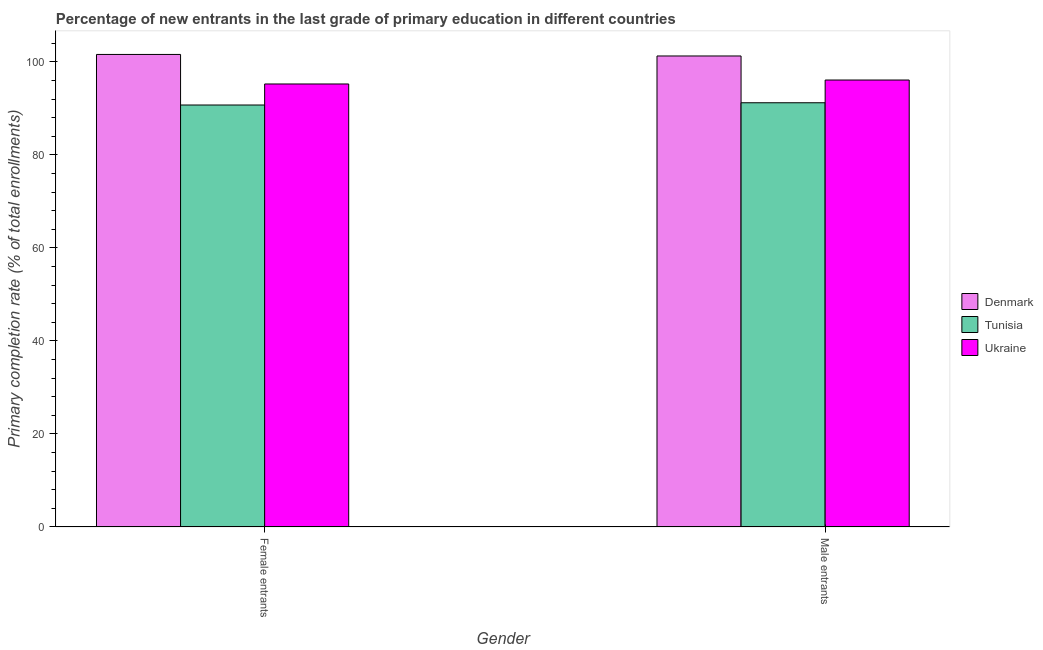How many groups of bars are there?
Your answer should be compact. 2. Are the number of bars on each tick of the X-axis equal?
Make the answer very short. Yes. What is the label of the 1st group of bars from the left?
Make the answer very short. Female entrants. What is the primary completion rate of female entrants in Ukraine?
Ensure brevity in your answer.  95.24. Across all countries, what is the maximum primary completion rate of female entrants?
Offer a terse response. 101.58. Across all countries, what is the minimum primary completion rate of male entrants?
Keep it short and to the point. 91.2. In which country was the primary completion rate of female entrants minimum?
Provide a succinct answer. Tunisia. What is the total primary completion rate of female entrants in the graph?
Your response must be concise. 287.53. What is the difference between the primary completion rate of male entrants in Tunisia and that in Ukraine?
Offer a terse response. -4.89. What is the difference between the primary completion rate of female entrants in Denmark and the primary completion rate of male entrants in Tunisia?
Provide a short and direct response. 10.38. What is the average primary completion rate of female entrants per country?
Give a very brief answer. 95.84. What is the difference between the primary completion rate of male entrants and primary completion rate of female entrants in Denmark?
Ensure brevity in your answer.  -0.33. In how many countries, is the primary completion rate of male entrants greater than 84 %?
Provide a succinct answer. 3. What is the ratio of the primary completion rate of female entrants in Tunisia to that in Denmark?
Your answer should be very brief. 0.89. In how many countries, is the primary completion rate of male entrants greater than the average primary completion rate of male entrants taken over all countries?
Provide a short and direct response. 1. What does the 2nd bar from the left in Male entrants represents?
Give a very brief answer. Tunisia. What does the 2nd bar from the right in Male entrants represents?
Ensure brevity in your answer.  Tunisia. How many bars are there?
Offer a terse response. 6. Are all the bars in the graph horizontal?
Provide a succinct answer. No. How many countries are there in the graph?
Provide a succinct answer. 3. What is the difference between two consecutive major ticks on the Y-axis?
Offer a very short reply. 20. Does the graph contain grids?
Your response must be concise. No. How many legend labels are there?
Provide a succinct answer. 3. What is the title of the graph?
Provide a short and direct response. Percentage of new entrants in the last grade of primary education in different countries. What is the label or title of the X-axis?
Provide a succinct answer. Gender. What is the label or title of the Y-axis?
Your answer should be compact. Primary completion rate (% of total enrollments). What is the Primary completion rate (% of total enrollments) of Denmark in Female entrants?
Make the answer very short. 101.58. What is the Primary completion rate (% of total enrollments) in Tunisia in Female entrants?
Ensure brevity in your answer.  90.72. What is the Primary completion rate (% of total enrollments) of Ukraine in Female entrants?
Your answer should be compact. 95.24. What is the Primary completion rate (% of total enrollments) of Denmark in Male entrants?
Make the answer very short. 101.26. What is the Primary completion rate (% of total enrollments) of Tunisia in Male entrants?
Offer a very short reply. 91.2. What is the Primary completion rate (% of total enrollments) in Ukraine in Male entrants?
Your answer should be compact. 96.09. Across all Gender, what is the maximum Primary completion rate (% of total enrollments) of Denmark?
Keep it short and to the point. 101.58. Across all Gender, what is the maximum Primary completion rate (% of total enrollments) of Tunisia?
Offer a terse response. 91.2. Across all Gender, what is the maximum Primary completion rate (% of total enrollments) in Ukraine?
Your answer should be very brief. 96.09. Across all Gender, what is the minimum Primary completion rate (% of total enrollments) of Denmark?
Make the answer very short. 101.26. Across all Gender, what is the minimum Primary completion rate (% of total enrollments) of Tunisia?
Ensure brevity in your answer.  90.72. Across all Gender, what is the minimum Primary completion rate (% of total enrollments) in Ukraine?
Your answer should be compact. 95.24. What is the total Primary completion rate (% of total enrollments) in Denmark in the graph?
Give a very brief answer. 202.84. What is the total Primary completion rate (% of total enrollments) in Tunisia in the graph?
Ensure brevity in your answer.  181.92. What is the total Primary completion rate (% of total enrollments) of Ukraine in the graph?
Ensure brevity in your answer.  191.32. What is the difference between the Primary completion rate (% of total enrollments) of Denmark in Female entrants and that in Male entrants?
Make the answer very short. 0.33. What is the difference between the Primary completion rate (% of total enrollments) in Tunisia in Female entrants and that in Male entrants?
Your answer should be compact. -0.49. What is the difference between the Primary completion rate (% of total enrollments) in Ukraine in Female entrants and that in Male entrants?
Give a very brief answer. -0.85. What is the difference between the Primary completion rate (% of total enrollments) of Denmark in Female entrants and the Primary completion rate (% of total enrollments) of Tunisia in Male entrants?
Make the answer very short. 10.38. What is the difference between the Primary completion rate (% of total enrollments) in Denmark in Female entrants and the Primary completion rate (% of total enrollments) in Ukraine in Male entrants?
Your answer should be compact. 5.5. What is the difference between the Primary completion rate (% of total enrollments) of Tunisia in Female entrants and the Primary completion rate (% of total enrollments) of Ukraine in Male entrants?
Keep it short and to the point. -5.37. What is the average Primary completion rate (% of total enrollments) in Denmark per Gender?
Provide a short and direct response. 101.42. What is the average Primary completion rate (% of total enrollments) in Tunisia per Gender?
Provide a succinct answer. 90.96. What is the average Primary completion rate (% of total enrollments) of Ukraine per Gender?
Offer a terse response. 95.66. What is the difference between the Primary completion rate (% of total enrollments) of Denmark and Primary completion rate (% of total enrollments) of Tunisia in Female entrants?
Provide a short and direct response. 10.87. What is the difference between the Primary completion rate (% of total enrollments) of Denmark and Primary completion rate (% of total enrollments) of Ukraine in Female entrants?
Your answer should be very brief. 6.35. What is the difference between the Primary completion rate (% of total enrollments) in Tunisia and Primary completion rate (% of total enrollments) in Ukraine in Female entrants?
Your answer should be compact. -4.52. What is the difference between the Primary completion rate (% of total enrollments) of Denmark and Primary completion rate (% of total enrollments) of Tunisia in Male entrants?
Make the answer very short. 10.05. What is the difference between the Primary completion rate (% of total enrollments) of Denmark and Primary completion rate (% of total enrollments) of Ukraine in Male entrants?
Your answer should be very brief. 5.17. What is the difference between the Primary completion rate (% of total enrollments) in Tunisia and Primary completion rate (% of total enrollments) in Ukraine in Male entrants?
Provide a succinct answer. -4.89. What is the ratio of the Primary completion rate (% of total enrollments) of Tunisia in Female entrants to that in Male entrants?
Offer a very short reply. 0.99. What is the difference between the highest and the second highest Primary completion rate (% of total enrollments) of Denmark?
Offer a terse response. 0.33. What is the difference between the highest and the second highest Primary completion rate (% of total enrollments) of Tunisia?
Provide a short and direct response. 0.49. What is the difference between the highest and the second highest Primary completion rate (% of total enrollments) of Ukraine?
Your answer should be compact. 0.85. What is the difference between the highest and the lowest Primary completion rate (% of total enrollments) in Denmark?
Your answer should be very brief. 0.33. What is the difference between the highest and the lowest Primary completion rate (% of total enrollments) in Tunisia?
Your response must be concise. 0.49. What is the difference between the highest and the lowest Primary completion rate (% of total enrollments) in Ukraine?
Provide a short and direct response. 0.85. 